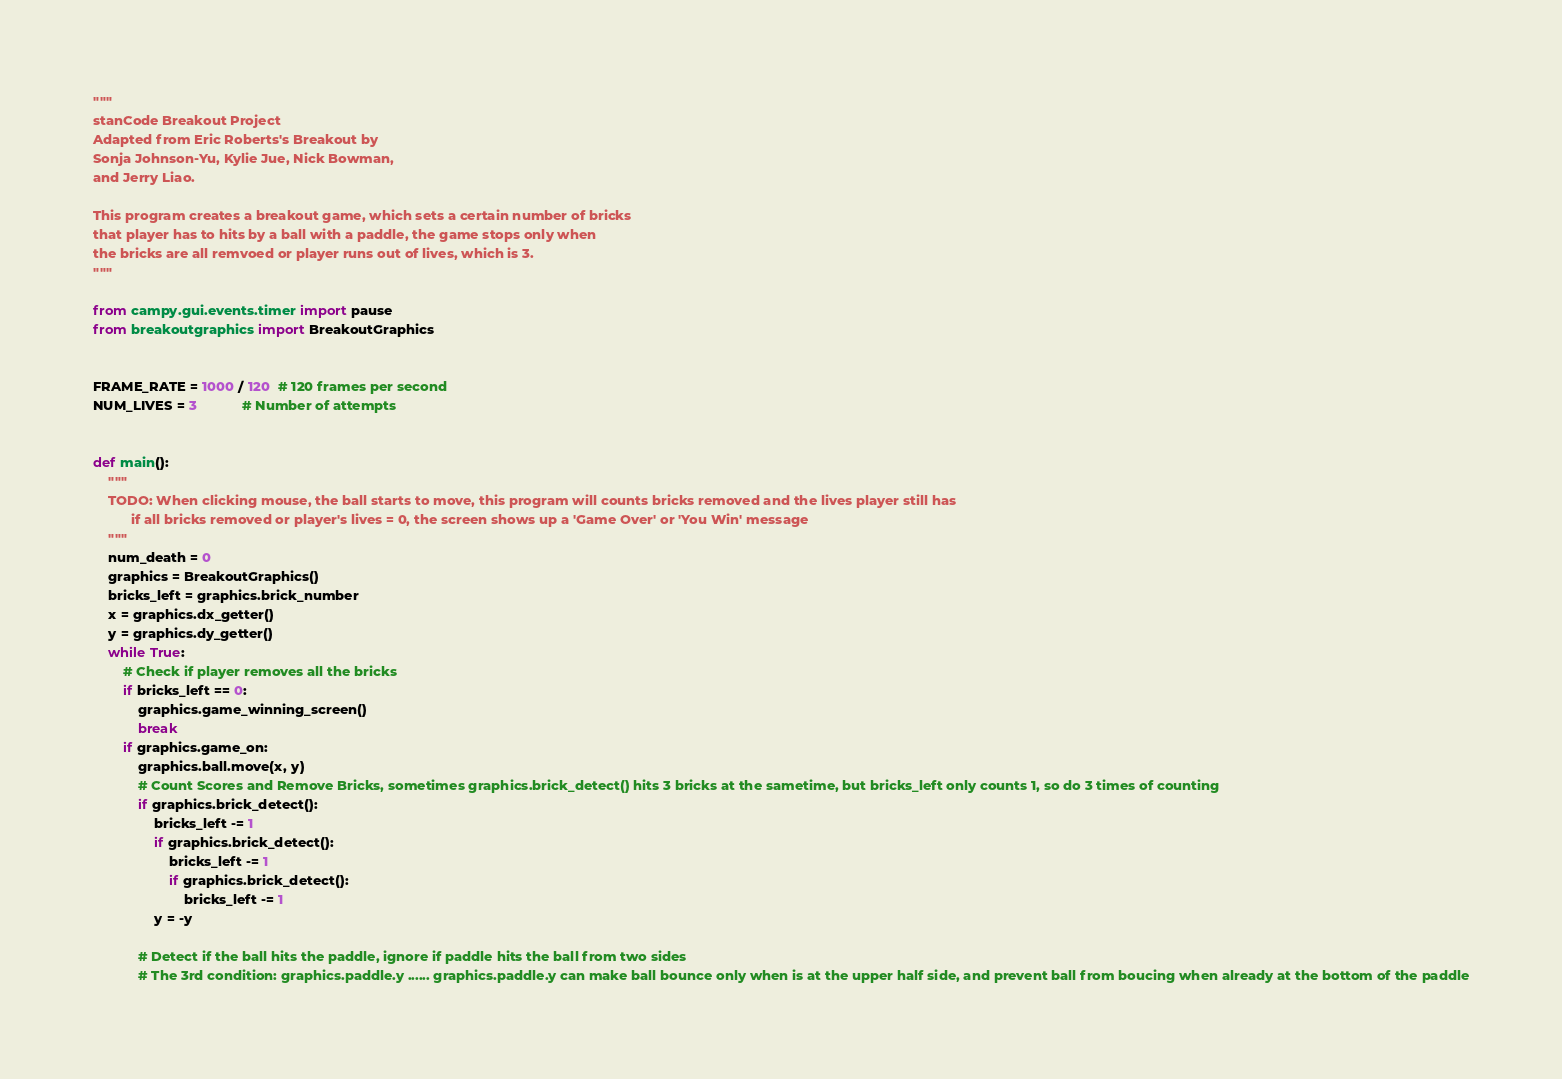Convert code to text. <code><loc_0><loc_0><loc_500><loc_500><_Python_>"""
stanCode Breakout Project
Adapted from Eric Roberts's Breakout by
Sonja Johnson-Yu, Kylie Jue, Nick Bowman,
and Jerry Liao.

This program creates a breakout game, which sets a certain number of bricks
that player has to hits by a ball with a paddle, the game stops only when
the bricks are all remvoed or player runs out of lives, which is 3.
"""

from campy.gui.events.timer import pause
from breakoutgraphics import BreakoutGraphics


FRAME_RATE = 1000 / 120  # 120 frames per second
NUM_LIVES = 3			# Number of attempts


def main():
    """
    TODO: When clicking mouse, the ball starts to move, this program will counts bricks removed and the lives player still has
          if all bricks removed or player's lives = 0, the screen shows up a 'Game Over' or 'You Win' message
    """
    num_death = 0
    graphics = BreakoutGraphics()
    bricks_left = graphics.brick_number
    x = graphics.dx_getter()
    y = graphics.dy_getter()
    while True:
        # Check if player removes all the bricks
        if bricks_left == 0:
            graphics.game_winning_screen()
            break
        if graphics.game_on:
            graphics.ball.move(x, y)
            # Count Scores and Remove Bricks, sometimes graphics.brick_detect() hits 3 bricks at the sametime, but bricks_left only counts 1, so do 3 times of counting
            if graphics.brick_detect():
                bricks_left -= 1
                if graphics.brick_detect():
                    bricks_left -= 1
                    if graphics.brick_detect():
                        bricks_left -= 1
                y = -y

            # Detect if the ball hits the paddle, ignore if paddle hits the ball from two sides
            # The 3rd condition: graphics.paddle.y ...... graphics.paddle.y can make ball bounce only when is at the upper half side, and prevent ball from boucing when already at the bottom of the paddle</code> 